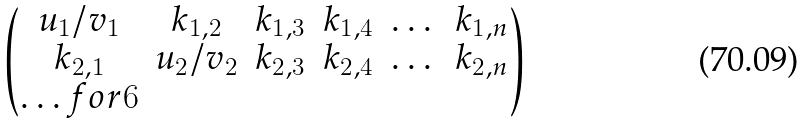Convert formula to latex. <formula><loc_0><loc_0><loc_500><loc_500>\begin{pmatrix} u _ { 1 } / v _ { 1 } & k _ { 1 , 2 } & k _ { 1 , 3 } & k _ { 1 , 4 } & \dots & k _ { 1 , n } \\ k _ { 2 , 1 } & u _ { 2 } / v _ { 2 } & k _ { 2 , 3 } & k _ { 2 , 4 } & \dots & k _ { 2 , n } \\ \hdots f o r { 6 } \\ \end{pmatrix}</formula> 